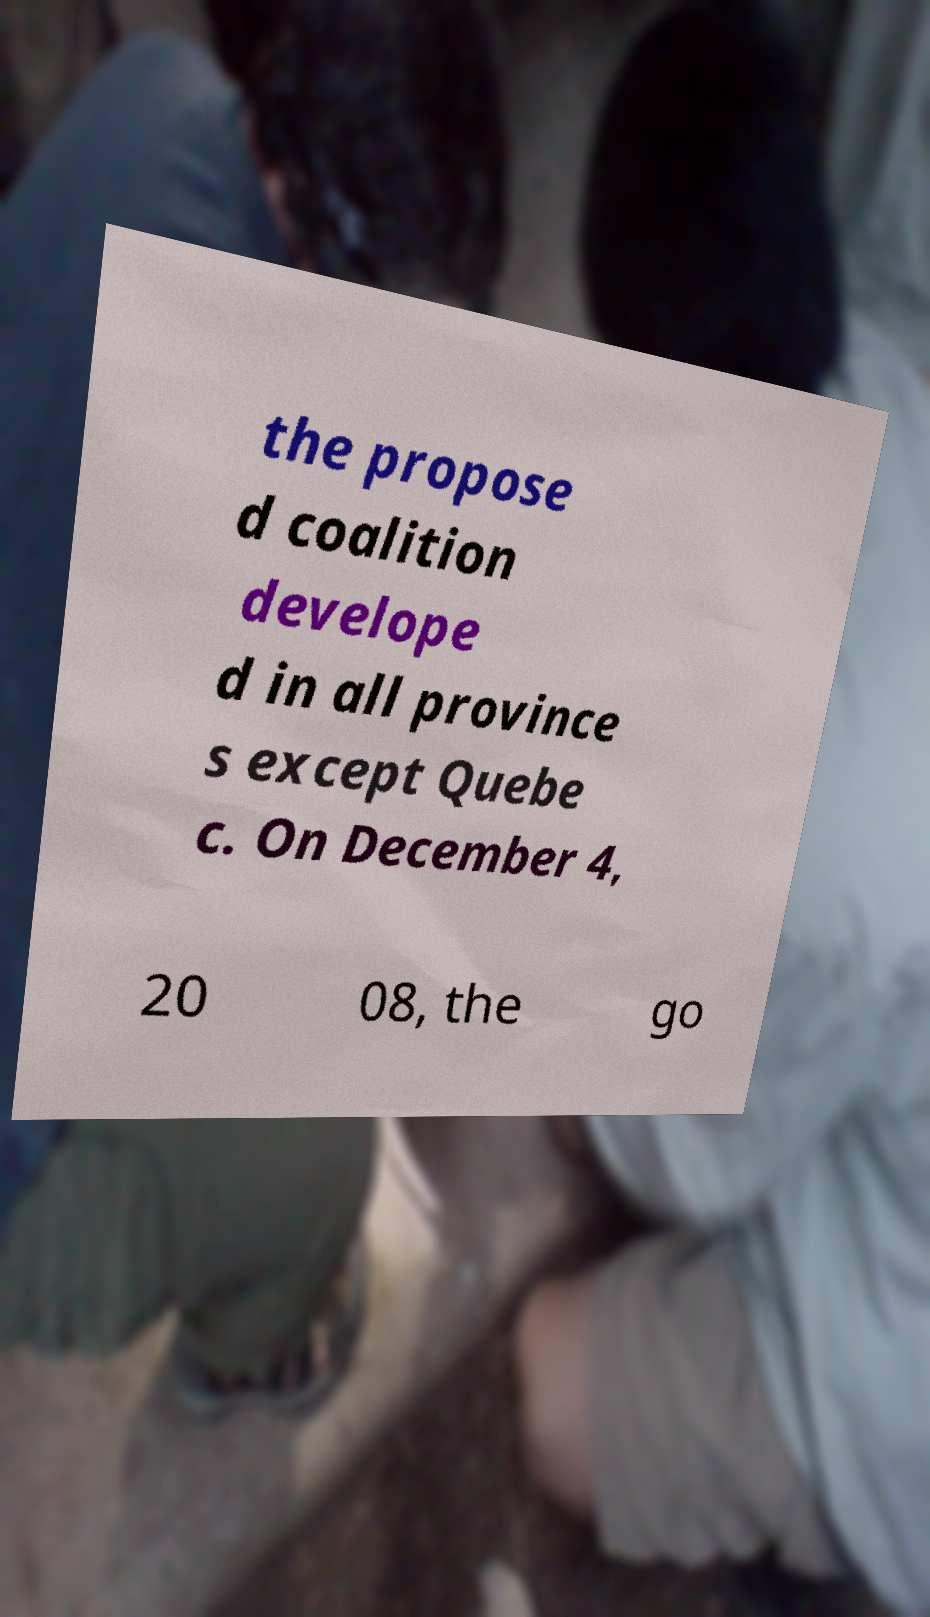Could you extract and type out the text from this image? the propose d coalition develope d in all province s except Quebe c. On December 4, 20 08, the go 